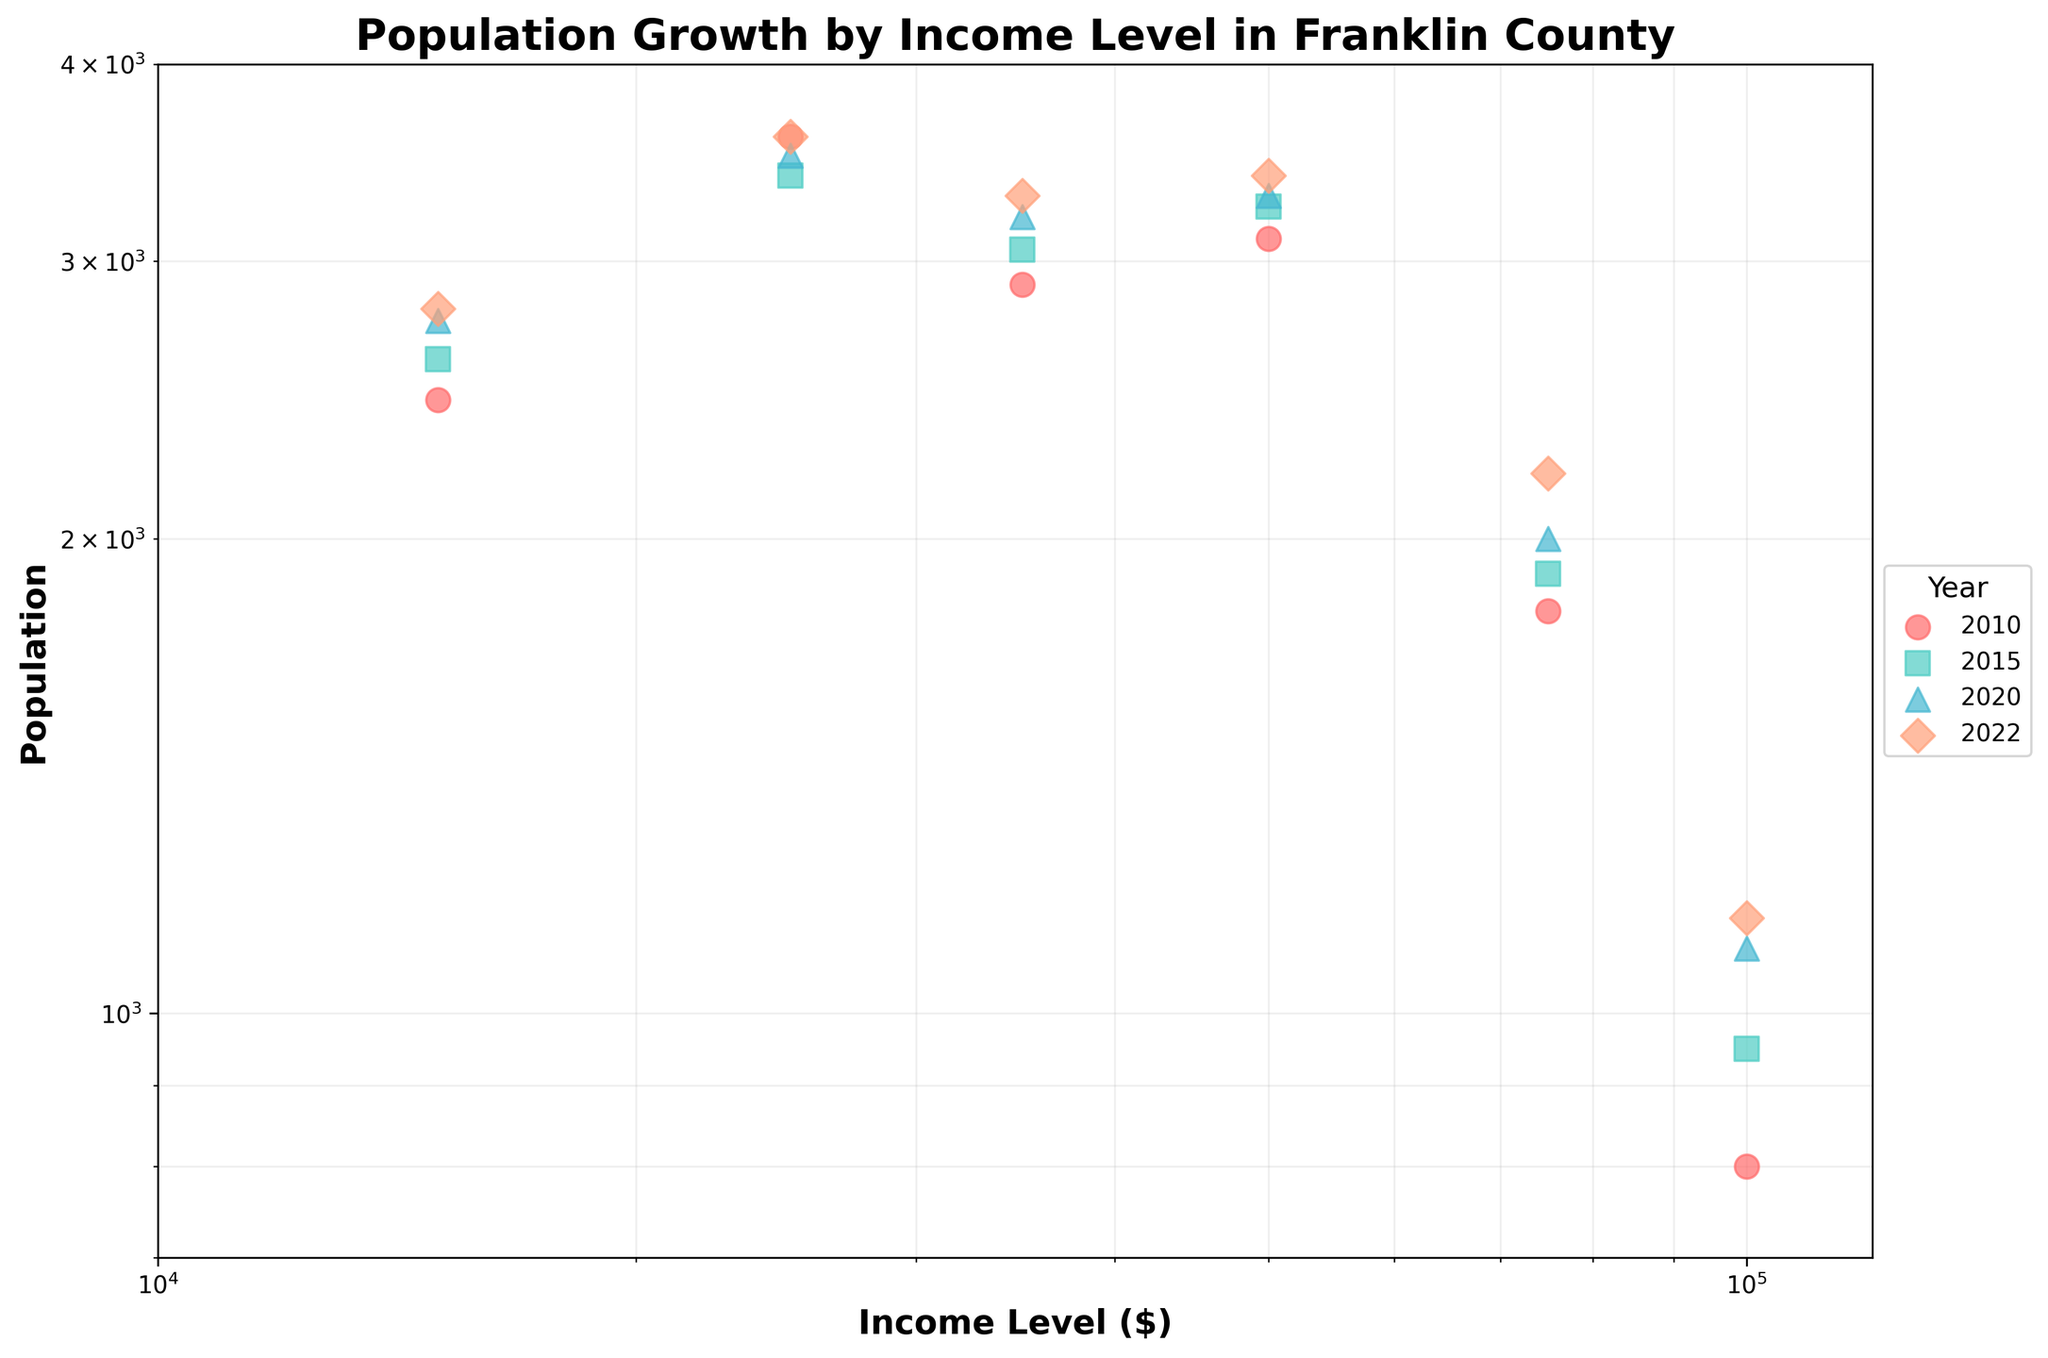What is the title of the figure? The title of the figure is located at the top and is often used to describe what the figure represents.
Answer: "Population Growth by Income Level in Franklin County" Which year has the highest population in the $50,000 income level? By looking at the y-axis values for the $50,000 income level across different years, you can identify which year's point is the highest.
Answer: 2022 How does the population in the $15,000 income level change from 2010 to 2022? Compare the y-axis values of the $15,000 income level points for the years 2010 and 2022.
Answer: It increases from 2450 to 2800 What is the color of the data points for the year 2022? By referring to the legend on the right, which maps years to colors, you can determine the color of the 2022 data points.
Answer: Light Blue Which income level shows the largest population increase from 2010 to 2022? Calculate the difference in population between 2022 and 2010 for each income level and find the maximum increase.
Answer: $100,000 income level Arrange the years in ascending order according to their populations at the $75,000 income level. Compare the y-axis values for the $75,000 income level across all years and list them in increasing order.
Answer: 2010, 2015, 2020, 2022 Is the population in the $100,000 income level higher in 2020 or in 2022? Compare the y-axis values of the $100,000 income level points for the years 2020 and 2022.
Answer: 2022 What is the general trend of population for the $25,000 income level from 2010 to 2022? Observe the pattern of the $25,000 income level points from 2010 to 2022.
Answer: Increasing How does the overall population trend across most income levels from 2010 to 2022? Look at the pattern for each income level from 2010 to 2022 to identify any common trends.
Answer: Increasing Are the data points for each year well-differentiated by color and marker? By reviewing the plot, check if different colors and markers help to clearly distinguish data from different years.
Answer: Yes 